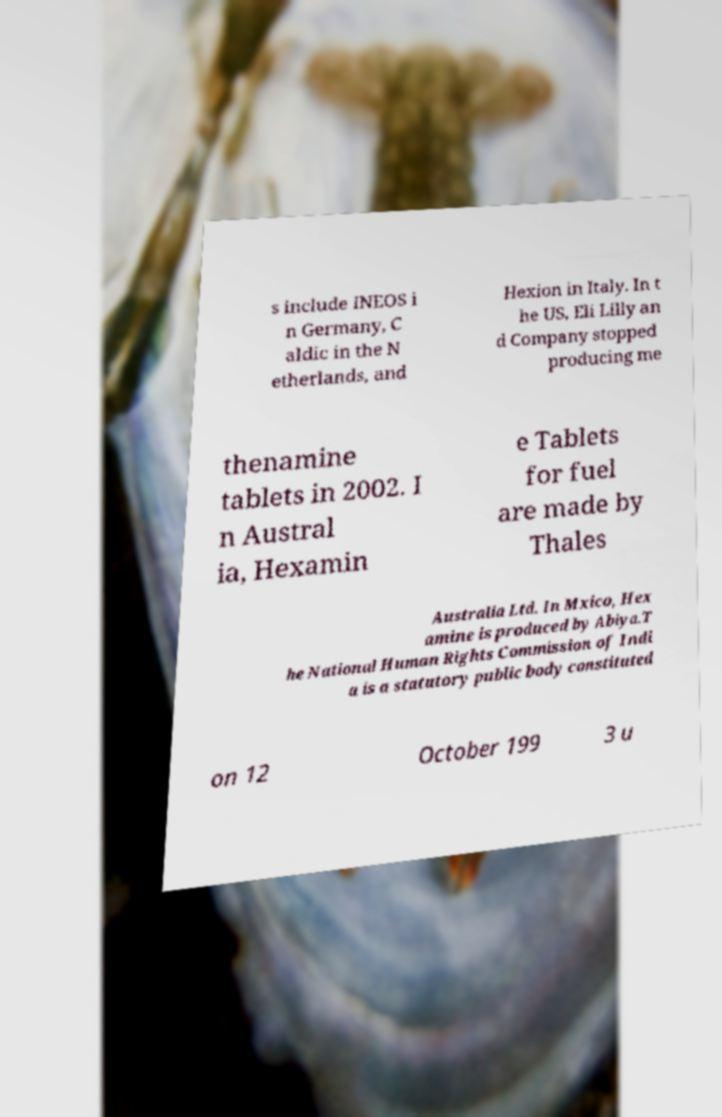What messages or text are displayed in this image? I need them in a readable, typed format. s include INEOS i n Germany, C aldic in the N etherlands, and Hexion in Italy. In t he US, Eli Lilly an d Company stopped producing me thenamine tablets in 2002. I n Austral ia, Hexamin e Tablets for fuel are made by Thales Australia Ltd. In Mxico, Hex amine is produced by Abiya.T he National Human Rights Commission of Indi a is a statutory public body constituted on 12 October 199 3 u 